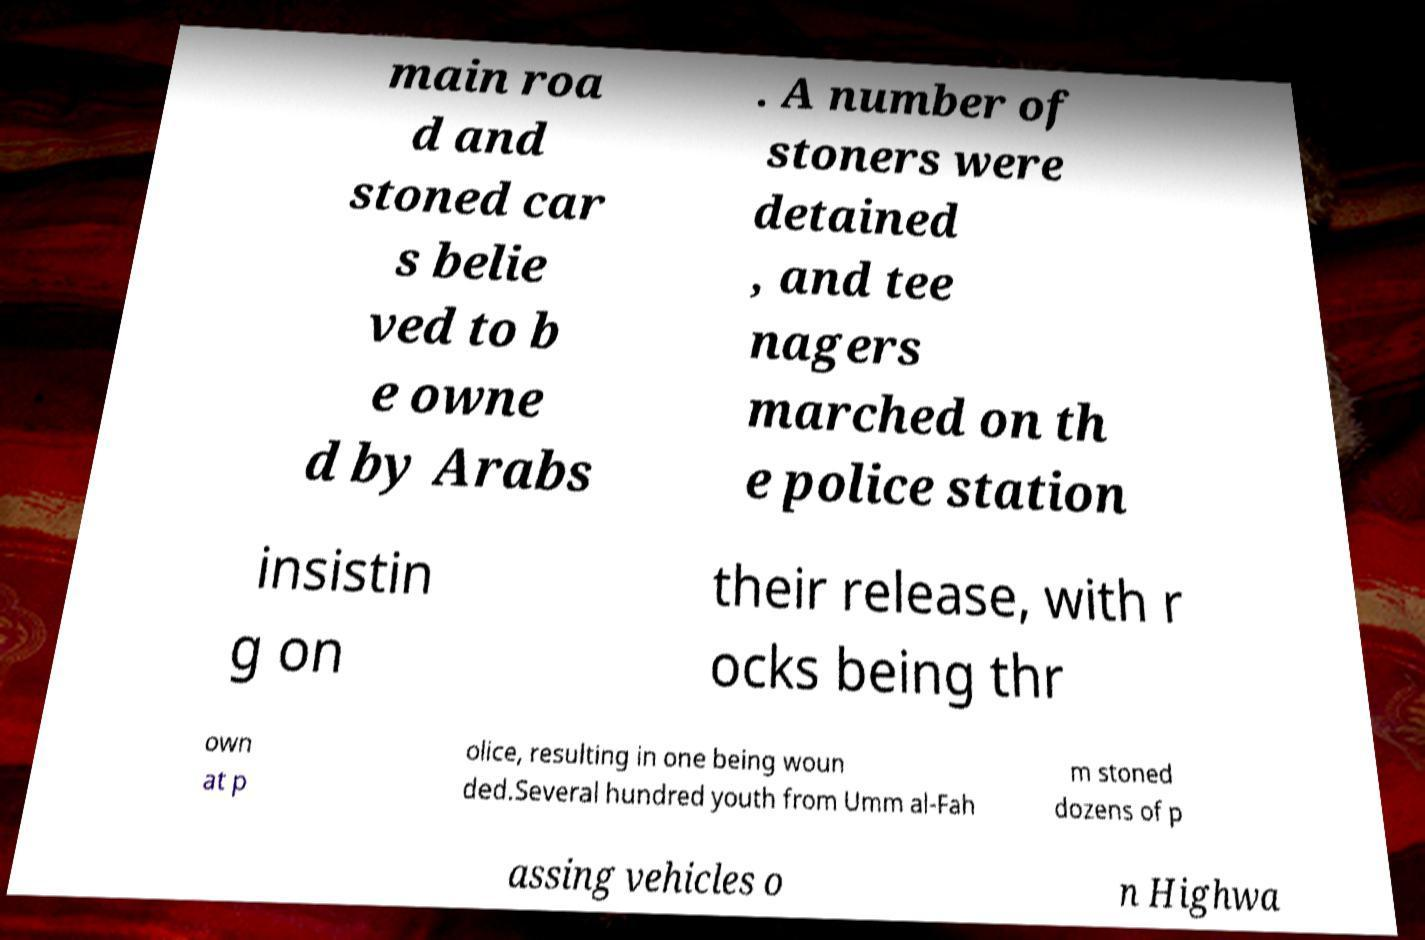Could you assist in decoding the text presented in this image and type it out clearly? main roa d and stoned car s belie ved to b e owne d by Arabs . A number of stoners were detained , and tee nagers marched on th e police station insistin g on their release, with r ocks being thr own at p olice, resulting in one being woun ded.Several hundred youth from Umm al-Fah m stoned dozens of p assing vehicles o n Highwa 